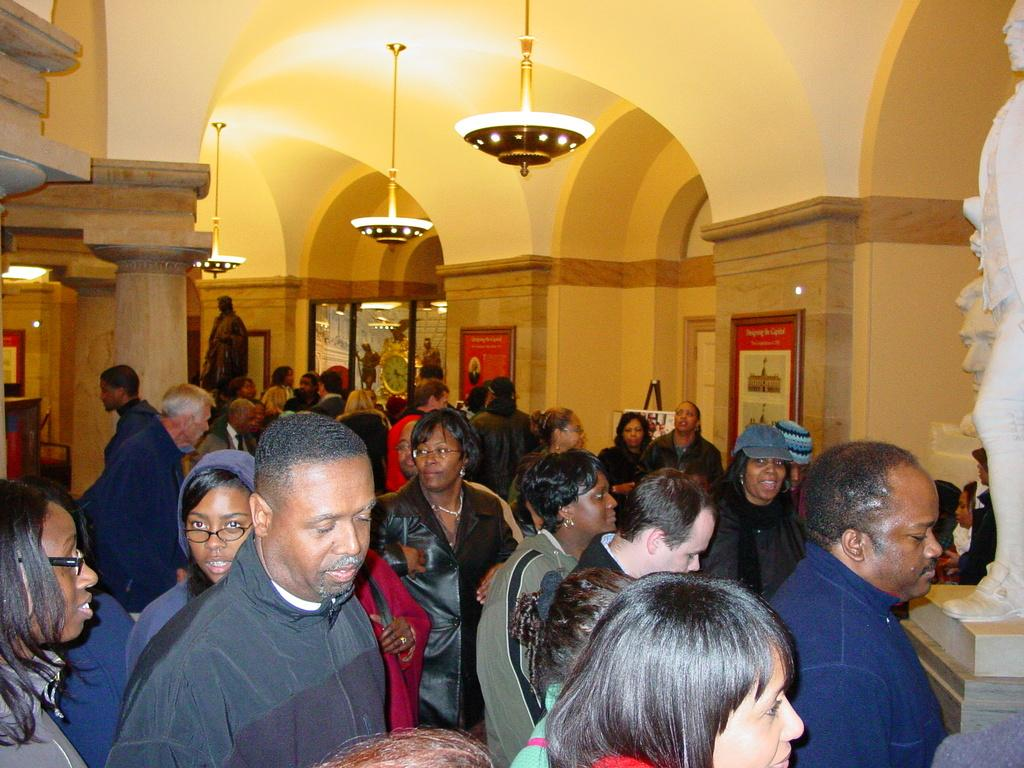What types of accessories can be seen in the image? There are caps and spectacles in the image. What types of structures are present in the image? There are statues, frames, a clock, lights, and pillars in the image. What is the composition of the group of people in the image? There is a group of people standing in the image. What other objects can be seen in the image? There are other objects in the image, but their specific details are not mentioned in the provided facts. Can you smell the scent of the volcano in the image? There is no mention of a volcano or any scent in the provided facts, so it cannot be determined from the image. 